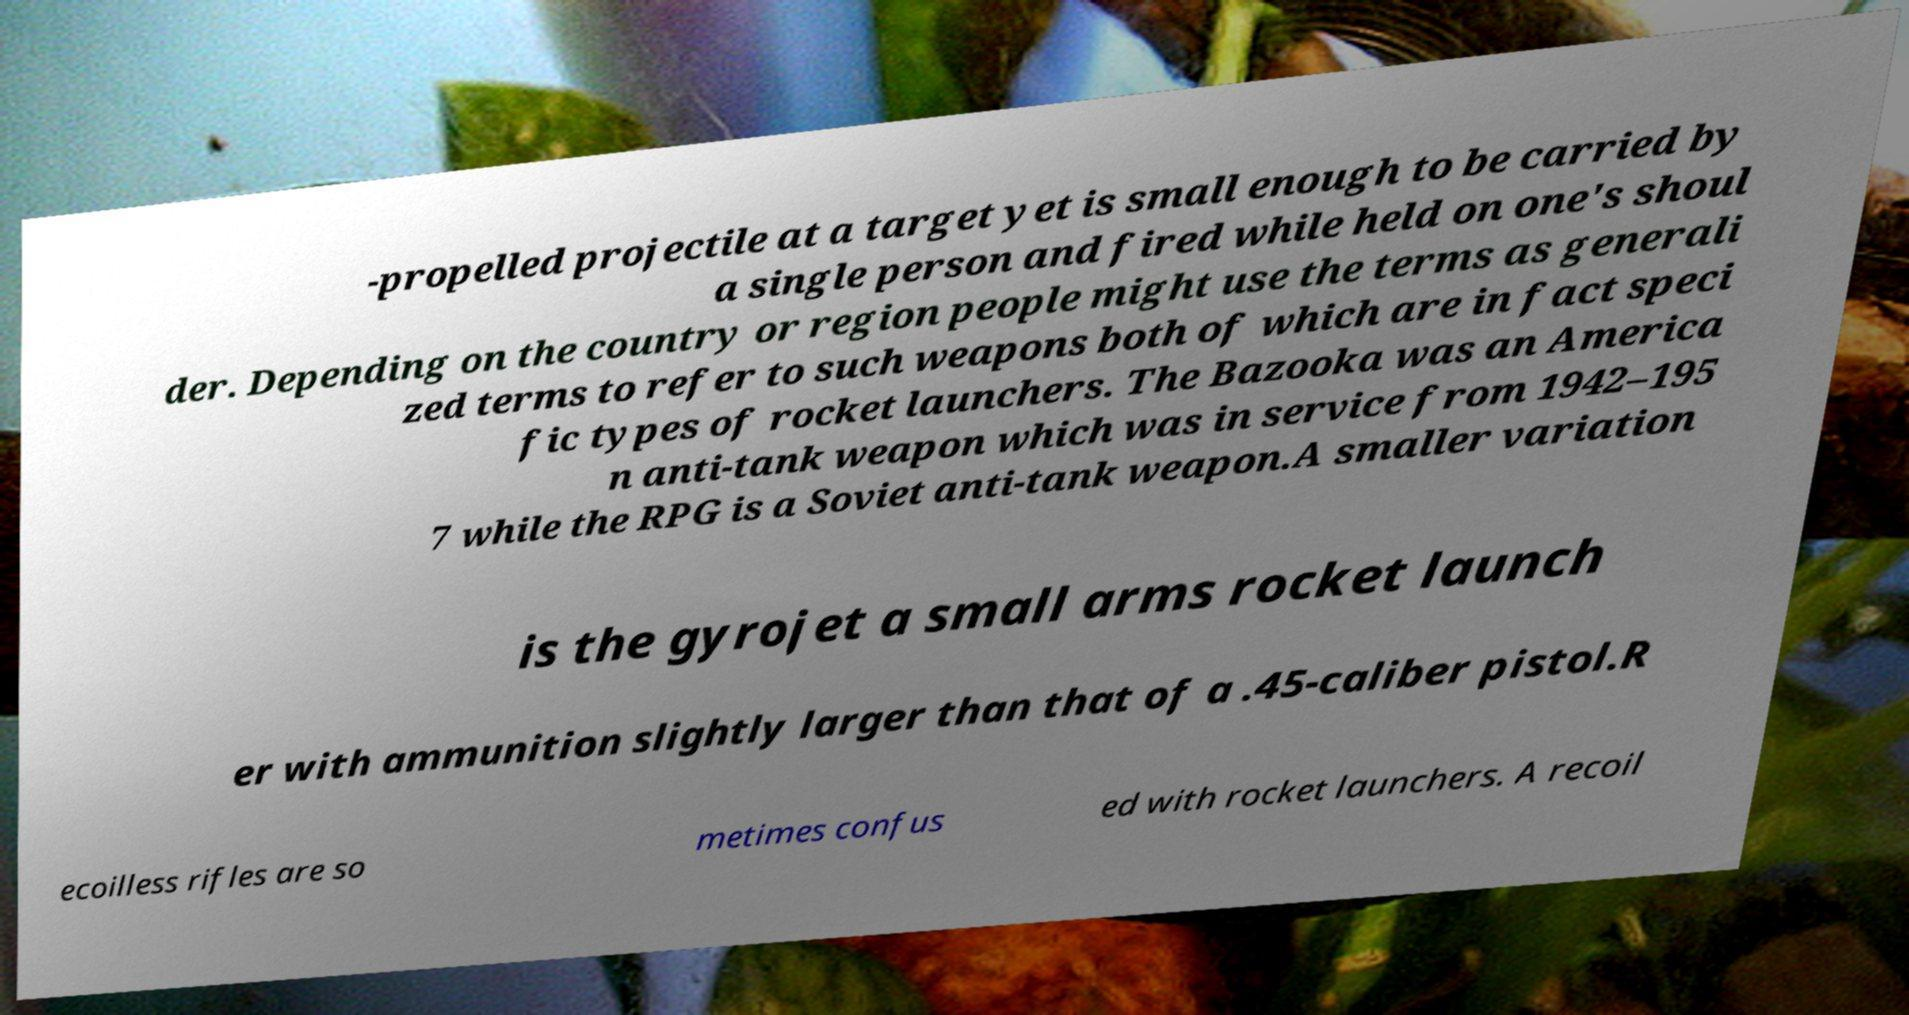Please identify and transcribe the text found in this image. -propelled projectile at a target yet is small enough to be carried by a single person and fired while held on one's shoul der. Depending on the country or region people might use the terms as generali zed terms to refer to such weapons both of which are in fact speci fic types of rocket launchers. The Bazooka was an America n anti-tank weapon which was in service from 1942–195 7 while the RPG is a Soviet anti-tank weapon.A smaller variation is the gyrojet a small arms rocket launch er with ammunition slightly larger than that of a .45-caliber pistol.R ecoilless rifles are so metimes confus ed with rocket launchers. A recoil 